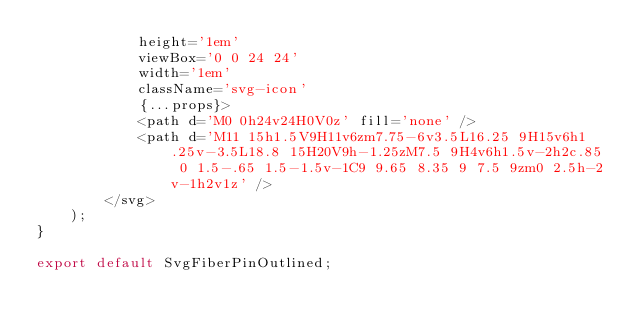<code> <loc_0><loc_0><loc_500><loc_500><_JavaScript_>			height='1em'
			viewBox='0 0 24 24'
			width='1em'
			className='svg-icon'
			{...props}>
			<path d='M0 0h24v24H0V0z' fill='none' />
			<path d='M11 15h1.5V9H11v6zm7.75-6v3.5L16.25 9H15v6h1.25v-3.5L18.8 15H20V9h-1.25zM7.5 9H4v6h1.5v-2h2c.85 0 1.5-.65 1.5-1.5v-1C9 9.65 8.35 9 7.5 9zm0 2.5h-2v-1h2v1z' />
		</svg>
	);
}

export default SvgFiberPinOutlined;
</code> 